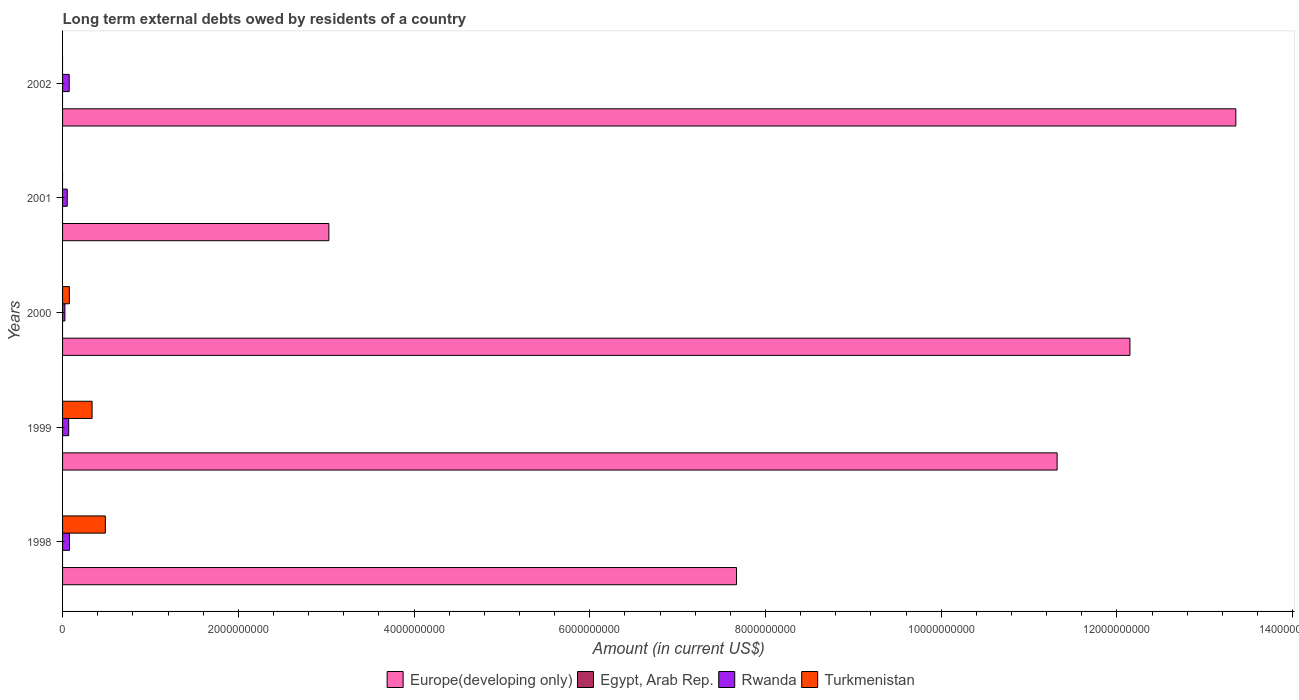How many groups of bars are there?
Provide a short and direct response. 5. Are the number of bars on each tick of the Y-axis equal?
Your answer should be compact. No. How many bars are there on the 4th tick from the bottom?
Offer a terse response. 2. What is the label of the 1st group of bars from the top?
Give a very brief answer. 2002. What is the amount of long-term external debts owed by residents in Egypt, Arab Rep. in 2001?
Give a very brief answer. 0. Across all years, what is the maximum amount of long-term external debts owed by residents in Europe(developing only)?
Keep it short and to the point. 1.34e+1. In which year was the amount of long-term external debts owed by residents in Rwanda maximum?
Ensure brevity in your answer.  1998. What is the difference between the amount of long-term external debts owed by residents in Turkmenistan in 1998 and that in 2000?
Your answer should be very brief. 4.10e+08. What is the difference between the amount of long-term external debts owed by residents in Rwanda in 1998 and the amount of long-term external debts owed by residents in Turkmenistan in 2002?
Offer a very short reply. 7.89e+07. What is the average amount of long-term external debts owed by residents in Egypt, Arab Rep. per year?
Ensure brevity in your answer.  0. In the year 2000, what is the difference between the amount of long-term external debts owed by residents in Turkmenistan and amount of long-term external debts owed by residents in Europe(developing only)?
Make the answer very short. -1.21e+1. In how many years, is the amount of long-term external debts owed by residents in Rwanda greater than 4800000000 US$?
Your answer should be very brief. 0. What is the ratio of the amount of long-term external debts owed by residents in Rwanda in 1998 to that in 2000?
Your answer should be very brief. 2.95. Is the difference between the amount of long-term external debts owed by residents in Turkmenistan in 1998 and 2000 greater than the difference between the amount of long-term external debts owed by residents in Europe(developing only) in 1998 and 2000?
Make the answer very short. Yes. What is the difference between the highest and the second highest amount of long-term external debts owed by residents in Europe(developing only)?
Give a very brief answer. 1.21e+09. What is the difference between the highest and the lowest amount of long-term external debts owed by residents in Turkmenistan?
Your response must be concise. 4.87e+08. In how many years, is the amount of long-term external debts owed by residents in Rwanda greater than the average amount of long-term external debts owed by residents in Rwanda taken over all years?
Your answer should be compact. 3. Is the sum of the amount of long-term external debts owed by residents in Rwanda in 1999 and 2002 greater than the maximum amount of long-term external debts owed by residents in Turkmenistan across all years?
Provide a succinct answer. No. Is it the case that in every year, the sum of the amount of long-term external debts owed by residents in Europe(developing only) and amount of long-term external debts owed by residents in Egypt, Arab Rep. is greater than the amount of long-term external debts owed by residents in Turkmenistan?
Offer a very short reply. Yes. Are all the bars in the graph horizontal?
Make the answer very short. Yes. How many years are there in the graph?
Ensure brevity in your answer.  5. What is the difference between two consecutive major ticks on the X-axis?
Offer a terse response. 2.00e+09. Does the graph contain any zero values?
Provide a succinct answer. Yes. Where does the legend appear in the graph?
Your response must be concise. Bottom center. How many legend labels are there?
Your response must be concise. 4. How are the legend labels stacked?
Offer a terse response. Horizontal. What is the title of the graph?
Provide a succinct answer. Long term external debts owed by residents of a country. What is the Amount (in current US$) in Europe(developing only) in 1998?
Your response must be concise. 7.67e+09. What is the Amount (in current US$) in Rwanda in 1998?
Provide a succinct answer. 7.89e+07. What is the Amount (in current US$) in Turkmenistan in 1998?
Provide a succinct answer. 4.87e+08. What is the Amount (in current US$) of Europe(developing only) in 1999?
Provide a succinct answer. 1.13e+1. What is the Amount (in current US$) of Egypt, Arab Rep. in 1999?
Make the answer very short. 0. What is the Amount (in current US$) of Rwanda in 1999?
Make the answer very short. 6.98e+07. What is the Amount (in current US$) in Turkmenistan in 1999?
Give a very brief answer. 3.36e+08. What is the Amount (in current US$) in Europe(developing only) in 2000?
Offer a terse response. 1.21e+1. What is the Amount (in current US$) of Egypt, Arab Rep. in 2000?
Make the answer very short. 0. What is the Amount (in current US$) in Rwanda in 2000?
Ensure brevity in your answer.  2.67e+07. What is the Amount (in current US$) of Turkmenistan in 2000?
Make the answer very short. 7.71e+07. What is the Amount (in current US$) of Europe(developing only) in 2001?
Make the answer very short. 3.03e+09. What is the Amount (in current US$) of Rwanda in 2001?
Provide a short and direct response. 5.32e+07. What is the Amount (in current US$) of Turkmenistan in 2001?
Provide a short and direct response. 0. What is the Amount (in current US$) of Europe(developing only) in 2002?
Ensure brevity in your answer.  1.34e+1. What is the Amount (in current US$) of Egypt, Arab Rep. in 2002?
Provide a succinct answer. 0. What is the Amount (in current US$) in Rwanda in 2002?
Ensure brevity in your answer.  7.56e+07. Across all years, what is the maximum Amount (in current US$) in Europe(developing only)?
Offer a terse response. 1.34e+1. Across all years, what is the maximum Amount (in current US$) of Rwanda?
Your answer should be compact. 7.89e+07. Across all years, what is the maximum Amount (in current US$) in Turkmenistan?
Offer a terse response. 4.87e+08. Across all years, what is the minimum Amount (in current US$) in Europe(developing only)?
Your answer should be very brief. 3.03e+09. Across all years, what is the minimum Amount (in current US$) in Rwanda?
Offer a very short reply. 2.67e+07. Across all years, what is the minimum Amount (in current US$) of Turkmenistan?
Provide a short and direct response. 0. What is the total Amount (in current US$) in Europe(developing only) in the graph?
Your response must be concise. 4.75e+1. What is the total Amount (in current US$) in Rwanda in the graph?
Ensure brevity in your answer.  3.04e+08. What is the total Amount (in current US$) of Turkmenistan in the graph?
Keep it short and to the point. 9.00e+08. What is the difference between the Amount (in current US$) of Europe(developing only) in 1998 and that in 1999?
Your answer should be very brief. -3.65e+09. What is the difference between the Amount (in current US$) of Rwanda in 1998 and that in 1999?
Your answer should be very brief. 9.10e+06. What is the difference between the Amount (in current US$) of Turkmenistan in 1998 and that in 1999?
Offer a very short reply. 1.51e+08. What is the difference between the Amount (in current US$) in Europe(developing only) in 1998 and that in 2000?
Ensure brevity in your answer.  -4.48e+09. What is the difference between the Amount (in current US$) of Rwanda in 1998 and that in 2000?
Provide a succinct answer. 5.22e+07. What is the difference between the Amount (in current US$) of Turkmenistan in 1998 and that in 2000?
Give a very brief answer. 4.10e+08. What is the difference between the Amount (in current US$) of Europe(developing only) in 1998 and that in 2001?
Give a very brief answer. 4.64e+09. What is the difference between the Amount (in current US$) in Rwanda in 1998 and that in 2001?
Your answer should be compact. 2.57e+07. What is the difference between the Amount (in current US$) in Europe(developing only) in 1998 and that in 2002?
Your answer should be very brief. -5.68e+09. What is the difference between the Amount (in current US$) of Rwanda in 1998 and that in 2002?
Provide a short and direct response. 3.30e+06. What is the difference between the Amount (in current US$) in Europe(developing only) in 1999 and that in 2000?
Provide a short and direct response. -8.29e+08. What is the difference between the Amount (in current US$) in Rwanda in 1999 and that in 2000?
Offer a terse response. 4.30e+07. What is the difference between the Amount (in current US$) in Turkmenistan in 1999 and that in 2000?
Offer a terse response. 2.59e+08. What is the difference between the Amount (in current US$) of Europe(developing only) in 1999 and that in 2001?
Provide a short and direct response. 8.29e+09. What is the difference between the Amount (in current US$) in Rwanda in 1999 and that in 2001?
Provide a succinct answer. 1.66e+07. What is the difference between the Amount (in current US$) of Europe(developing only) in 1999 and that in 2002?
Offer a very short reply. -2.03e+09. What is the difference between the Amount (in current US$) in Rwanda in 1999 and that in 2002?
Your answer should be very brief. -5.80e+06. What is the difference between the Amount (in current US$) of Europe(developing only) in 2000 and that in 2001?
Your answer should be compact. 9.12e+09. What is the difference between the Amount (in current US$) in Rwanda in 2000 and that in 2001?
Offer a very short reply. -2.65e+07. What is the difference between the Amount (in current US$) of Europe(developing only) in 2000 and that in 2002?
Ensure brevity in your answer.  -1.21e+09. What is the difference between the Amount (in current US$) in Rwanda in 2000 and that in 2002?
Provide a short and direct response. -4.89e+07. What is the difference between the Amount (in current US$) of Europe(developing only) in 2001 and that in 2002?
Make the answer very short. -1.03e+1. What is the difference between the Amount (in current US$) in Rwanda in 2001 and that in 2002?
Your answer should be very brief. -2.24e+07. What is the difference between the Amount (in current US$) in Europe(developing only) in 1998 and the Amount (in current US$) in Rwanda in 1999?
Your answer should be very brief. 7.60e+09. What is the difference between the Amount (in current US$) in Europe(developing only) in 1998 and the Amount (in current US$) in Turkmenistan in 1999?
Your answer should be compact. 7.33e+09. What is the difference between the Amount (in current US$) of Rwanda in 1998 and the Amount (in current US$) of Turkmenistan in 1999?
Provide a succinct answer. -2.57e+08. What is the difference between the Amount (in current US$) in Europe(developing only) in 1998 and the Amount (in current US$) in Rwanda in 2000?
Your answer should be very brief. 7.64e+09. What is the difference between the Amount (in current US$) in Europe(developing only) in 1998 and the Amount (in current US$) in Turkmenistan in 2000?
Give a very brief answer. 7.59e+09. What is the difference between the Amount (in current US$) in Rwanda in 1998 and the Amount (in current US$) in Turkmenistan in 2000?
Give a very brief answer. 1.71e+06. What is the difference between the Amount (in current US$) in Europe(developing only) in 1998 and the Amount (in current US$) in Rwanda in 2001?
Your answer should be compact. 7.62e+09. What is the difference between the Amount (in current US$) of Europe(developing only) in 1998 and the Amount (in current US$) of Rwanda in 2002?
Offer a terse response. 7.60e+09. What is the difference between the Amount (in current US$) in Europe(developing only) in 1999 and the Amount (in current US$) in Rwanda in 2000?
Ensure brevity in your answer.  1.13e+1. What is the difference between the Amount (in current US$) of Europe(developing only) in 1999 and the Amount (in current US$) of Turkmenistan in 2000?
Your answer should be very brief. 1.12e+1. What is the difference between the Amount (in current US$) of Rwanda in 1999 and the Amount (in current US$) of Turkmenistan in 2000?
Keep it short and to the point. -7.39e+06. What is the difference between the Amount (in current US$) of Europe(developing only) in 1999 and the Amount (in current US$) of Rwanda in 2001?
Make the answer very short. 1.13e+1. What is the difference between the Amount (in current US$) in Europe(developing only) in 1999 and the Amount (in current US$) in Rwanda in 2002?
Offer a very short reply. 1.12e+1. What is the difference between the Amount (in current US$) in Europe(developing only) in 2000 and the Amount (in current US$) in Rwanda in 2001?
Provide a short and direct response. 1.21e+1. What is the difference between the Amount (in current US$) in Europe(developing only) in 2000 and the Amount (in current US$) in Rwanda in 2002?
Ensure brevity in your answer.  1.21e+1. What is the difference between the Amount (in current US$) in Europe(developing only) in 2001 and the Amount (in current US$) in Rwanda in 2002?
Offer a terse response. 2.96e+09. What is the average Amount (in current US$) in Europe(developing only) per year?
Ensure brevity in your answer.  9.50e+09. What is the average Amount (in current US$) in Rwanda per year?
Keep it short and to the point. 6.08e+07. What is the average Amount (in current US$) in Turkmenistan per year?
Provide a succinct answer. 1.80e+08. In the year 1998, what is the difference between the Amount (in current US$) in Europe(developing only) and Amount (in current US$) in Rwanda?
Keep it short and to the point. 7.59e+09. In the year 1998, what is the difference between the Amount (in current US$) of Europe(developing only) and Amount (in current US$) of Turkmenistan?
Offer a very short reply. 7.18e+09. In the year 1998, what is the difference between the Amount (in current US$) of Rwanda and Amount (in current US$) of Turkmenistan?
Ensure brevity in your answer.  -4.08e+08. In the year 1999, what is the difference between the Amount (in current US$) in Europe(developing only) and Amount (in current US$) in Rwanda?
Make the answer very short. 1.12e+1. In the year 1999, what is the difference between the Amount (in current US$) of Europe(developing only) and Amount (in current US$) of Turkmenistan?
Provide a short and direct response. 1.10e+1. In the year 1999, what is the difference between the Amount (in current US$) of Rwanda and Amount (in current US$) of Turkmenistan?
Offer a very short reply. -2.66e+08. In the year 2000, what is the difference between the Amount (in current US$) in Europe(developing only) and Amount (in current US$) in Rwanda?
Provide a short and direct response. 1.21e+1. In the year 2000, what is the difference between the Amount (in current US$) in Europe(developing only) and Amount (in current US$) in Turkmenistan?
Your response must be concise. 1.21e+1. In the year 2000, what is the difference between the Amount (in current US$) of Rwanda and Amount (in current US$) of Turkmenistan?
Provide a succinct answer. -5.04e+07. In the year 2001, what is the difference between the Amount (in current US$) in Europe(developing only) and Amount (in current US$) in Rwanda?
Ensure brevity in your answer.  2.98e+09. In the year 2002, what is the difference between the Amount (in current US$) of Europe(developing only) and Amount (in current US$) of Rwanda?
Your answer should be compact. 1.33e+1. What is the ratio of the Amount (in current US$) of Europe(developing only) in 1998 to that in 1999?
Your response must be concise. 0.68. What is the ratio of the Amount (in current US$) of Rwanda in 1998 to that in 1999?
Your answer should be very brief. 1.13. What is the ratio of the Amount (in current US$) of Turkmenistan in 1998 to that in 1999?
Ensure brevity in your answer.  1.45. What is the ratio of the Amount (in current US$) of Europe(developing only) in 1998 to that in 2000?
Provide a succinct answer. 0.63. What is the ratio of the Amount (in current US$) of Rwanda in 1998 to that in 2000?
Your answer should be very brief. 2.95. What is the ratio of the Amount (in current US$) of Turkmenistan in 1998 to that in 2000?
Provide a short and direct response. 6.31. What is the ratio of the Amount (in current US$) of Europe(developing only) in 1998 to that in 2001?
Make the answer very short. 2.53. What is the ratio of the Amount (in current US$) in Rwanda in 1998 to that in 2001?
Ensure brevity in your answer.  1.48. What is the ratio of the Amount (in current US$) of Europe(developing only) in 1998 to that in 2002?
Provide a short and direct response. 0.57. What is the ratio of the Amount (in current US$) of Rwanda in 1998 to that in 2002?
Ensure brevity in your answer.  1.04. What is the ratio of the Amount (in current US$) of Europe(developing only) in 1999 to that in 2000?
Make the answer very short. 0.93. What is the ratio of the Amount (in current US$) in Rwanda in 1999 to that in 2000?
Keep it short and to the point. 2.61. What is the ratio of the Amount (in current US$) of Turkmenistan in 1999 to that in 2000?
Make the answer very short. 4.36. What is the ratio of the Amount (in current US$) in Europe(developing only) in 1999 to that in 2001?
Provide a succinct answer. 3.73. What is the ratio of the Amount (in current US$) of Rwanda in 1999 to that in 2001?
Provide a succinct answer. 1.31. What is the ratio of the Amount (in current US$) in Europe(developing only) in 1999 to that in 2002?
Provide a short and direct response. 0.85. What is the ratio of the Amount (in current US$) of Rwanda in 1999 to that in 2002?
Offer a very short reply. 0.92. What is the ratio of the Amount (in current US$) in Europe(developing only) in 2000 to that in 2001?
Provide a short and direct response. 4.01. What is the ratio of the Amount (in current US$) of Rwanda in 2000 to that in 2001?
Provide a succinct answer. 0.5. What is the ratio of the Amount (in current US$) of Europe(developing only) in 2000 to that in 2002?
Offer a very short reply. 0.91. What is the ratio of the Amount (in current US$) in Rwanda in 2000 to that in 2002?
Provide a succinct answer. 0.35. What is the ratio of the Amount (in current US$) of Europe(developing only) in 2001 to that in 2002?
Make the answer very short. 0.23. What is the ratio of the Amount (in current US$) in Rwanda in 2001 to that in 2002?
Give a very brief answer. 0.7. What is the difference between the highest and the second highest Amount (in current US$) of Europe(developing only)?
Give a very brief answer. 1.21e+09. What is the difference between the highest and the second highest Amount (in current US$) of Rwanda?
Ensure brevity in your answer.  3.30e+06. What is the difference between the highest and the second highest Amount (in current US$) of Turkmenistan?
Offer a terse response. 1.51e+08. What is the difference between the highest and the lowest Amount (in current US$) in Europe(developing only)?
Give a very brief answer. 1.03e+1. What is the difference between the highest and the lowest Amount (in current US$) in Rwanda?
Your response must be concise. 5.22e+07. What is the difference between the highest and the lowest Amount (in current US$) in Turkmenistan?
Ensure brevity in your answer.  4.87e+08. 